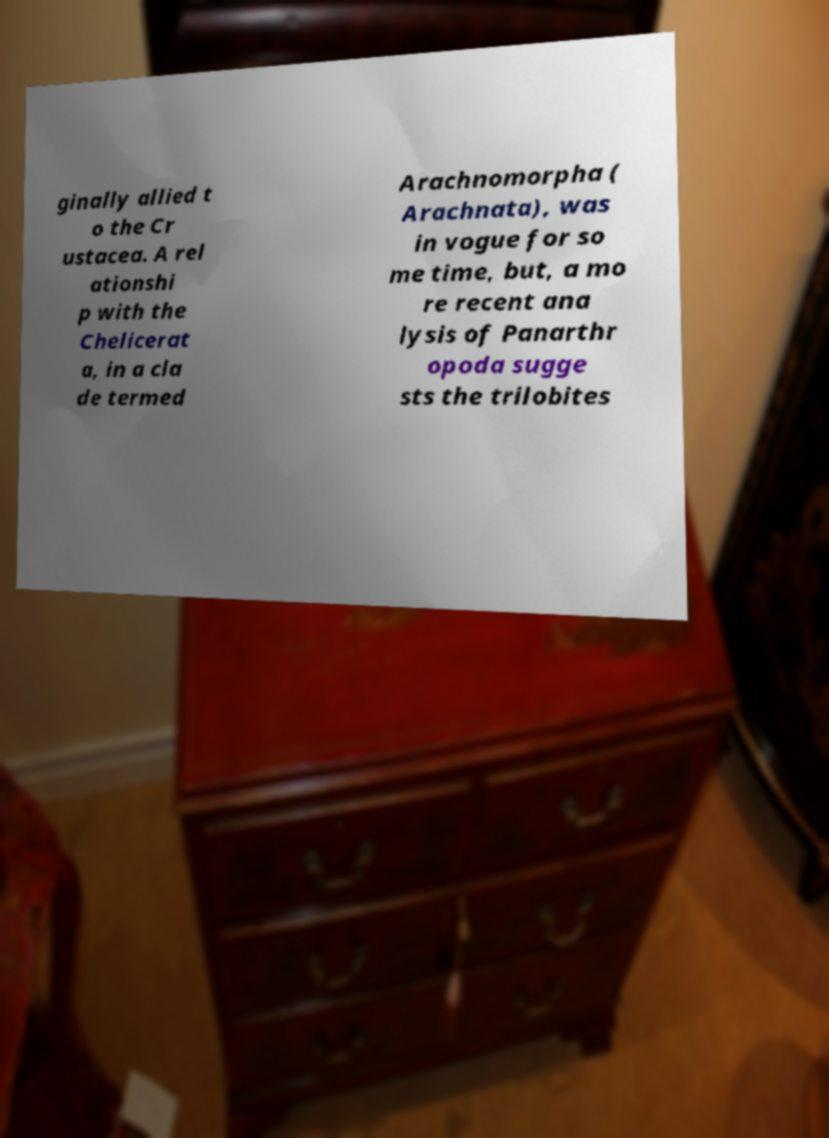I need the written content from this picture converted into text. Can you do that? ginally allied t o the Cr ustacea. A rel ationshi p with the Chelicerat a, in a cla de termed Arachnomorpha ( Arachnata), was in vogue for so me time, but, a mo re recent ana lysis of Panarthr opoda sugge sts the trilobites 